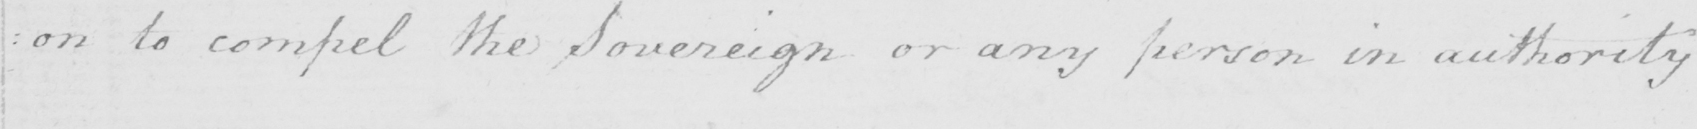What does this handwritten line say? : on to compel the Sovereign or any person in authority 